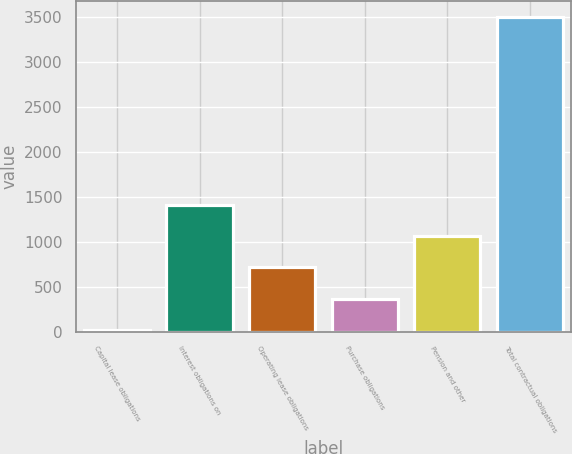Convert chart. <chart><loc_0><loc_0><loc_500><loc_500><bar_chart><fcel>Capital lease obligations<fcel>Interest obligations on<fcel>Operating lease obligations<fcel>Purchase obligations<fcel>Pension and other<fcel>Total contractual obligations<nl><fcel>21.5<fcel>1414.58<fcel>718.04<fcel>369.77<fcel>1066.31<fcel>3504.2<nl></chart> 